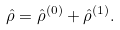<formula> <loc_0><loc_0><loc_500><loc_500>\hat { \rho } = \hat { \rho } ^ { ( 0 ) } + \hat { \rho } ^ { ( 1 ) } .</formula> 